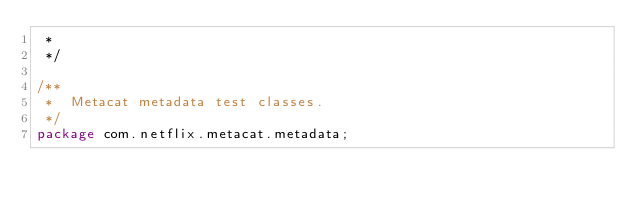Convert code to text. <code><loc_0><loc_0><loc_500><loc_500><_Java_> *
 */

/**
 *  Metacat metadata test classes.
 */
package com.netflix.metacat.metadata;
</code> 